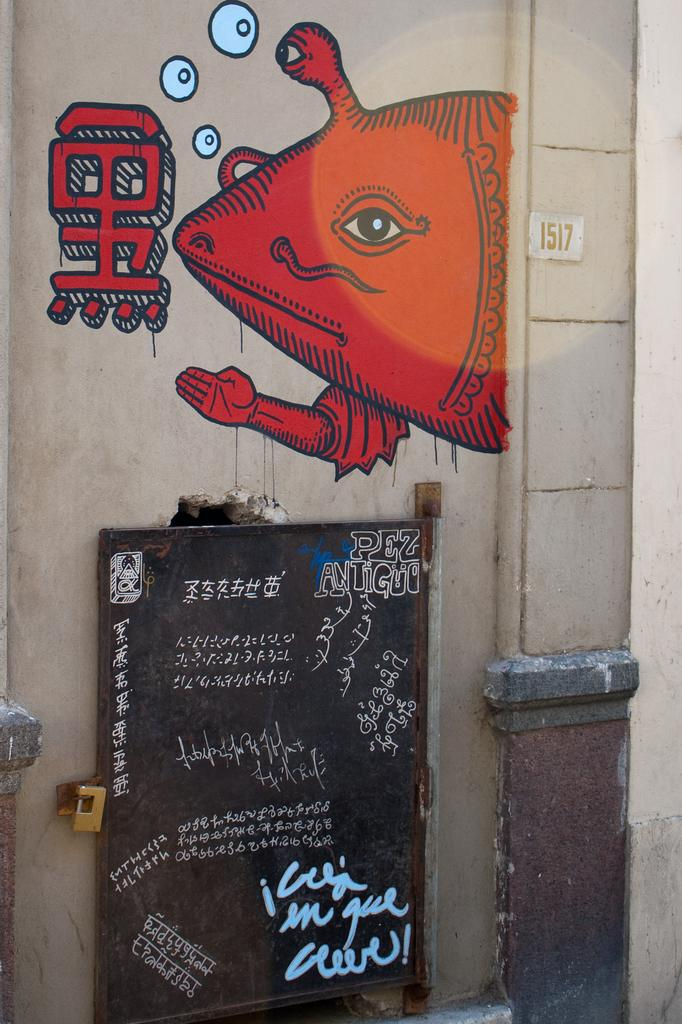What is depicted on the wall in the image? There is a painting on the wall in the image. What other object can be seen in the image besides the painting? There is a black color board in the image. What is written or drawn on the black color board? The black color board has text on it. How many cats are sitting on the black color board in the image? There are no cats present on the black color board or in the image. What verse is written on the black color board in the image? There is no verse written on the black color board in the image; it only has text. 